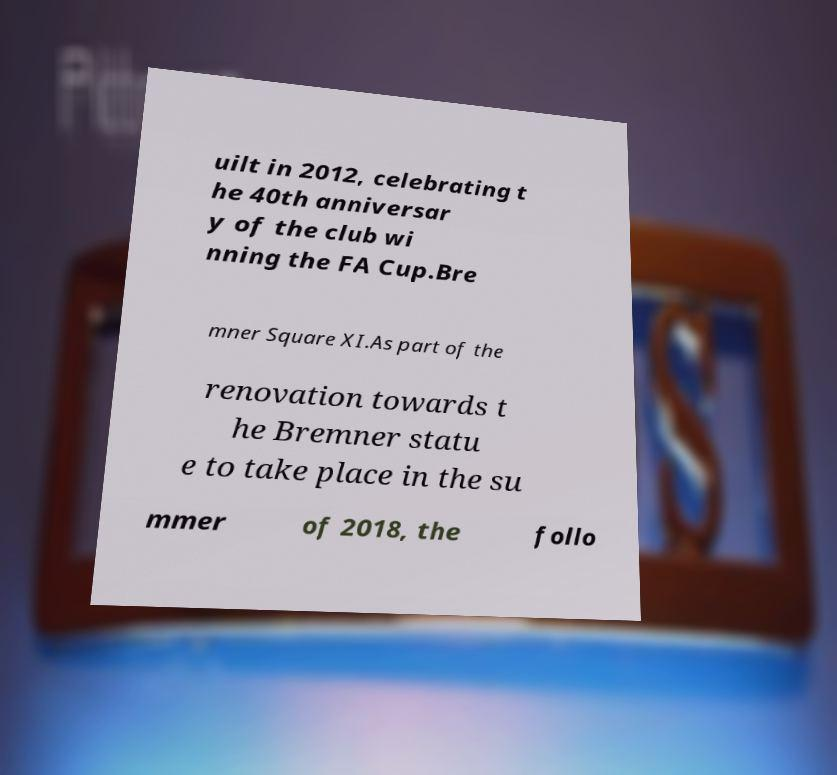I need the written content from this picture converted into text. Can you do that? uilt in 2012, celebrating t he 40th anniversar y of the club wi nning the FA Cup.Bre mner Square XI.As part of the renovation towards t he Bremner statu e to take place in the su mmer of 2018, the follo 